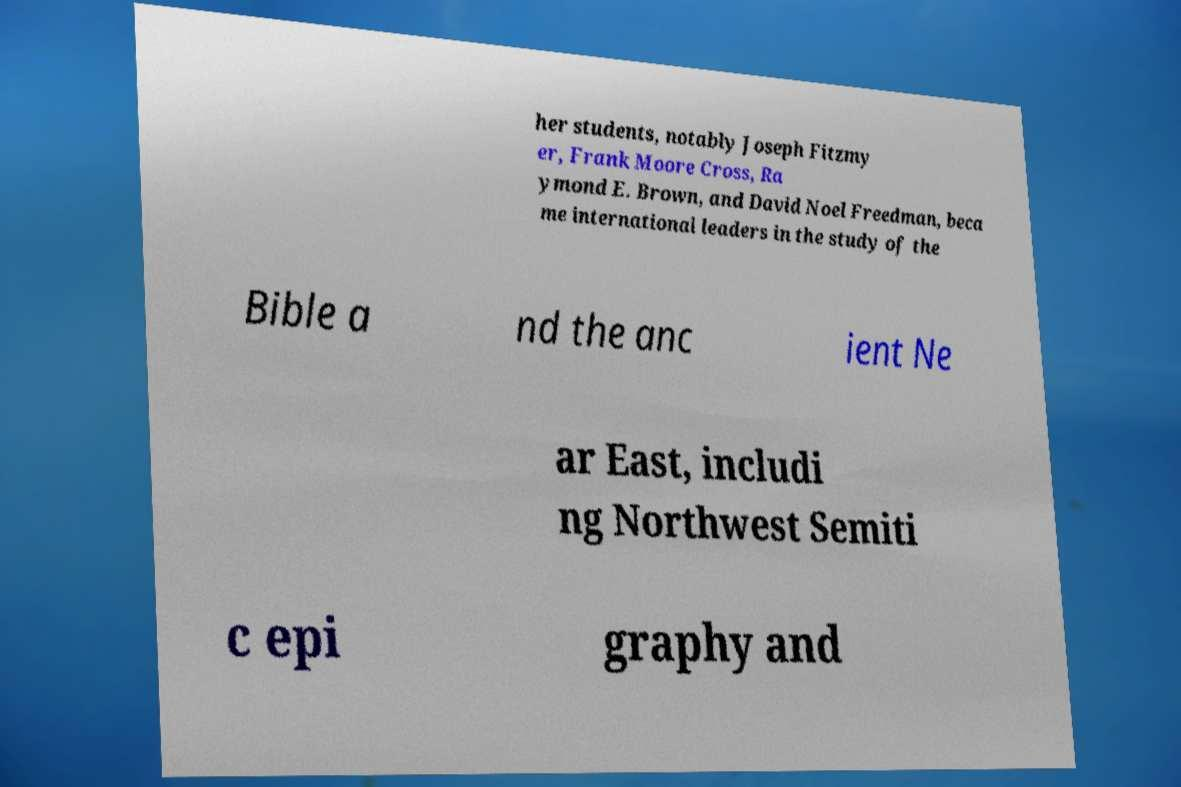Could you assist in decoding the text presented in this image and type it out clearly? her students, notably Joseph Fitzmy er, Frank Moore Cross, Ra ymond E. Brown, and David Noel Freedman, beca me international leaders in the study of the Bible a nd the anc ient Ne ar East, includi ng Northwest Semiti c epi graphy and 